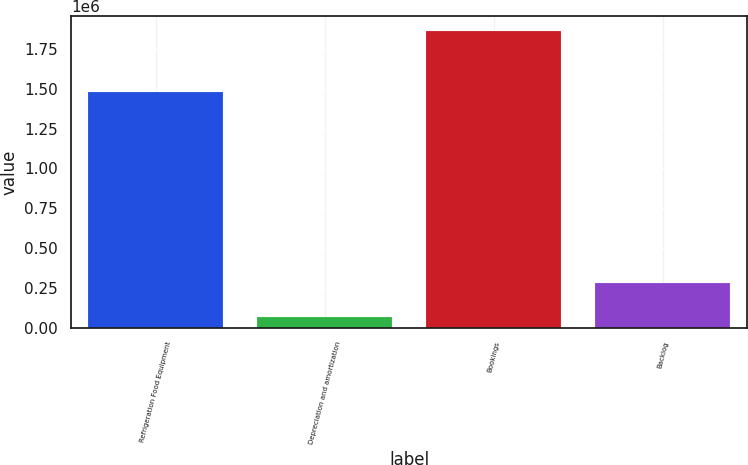Convert chart to OTSL. <chart><loc_0><loc_0><loc_500><loc_500><bar_chart><fcel>Refrigeration Food Equipment<fcel>Depreciation and amortization<fcel>Bookings<fcel>Backlog<nl><fcel>1.48316e+06<fcel>68701<fcel>1.86321e+06<fcel>282507<nl></chart> 